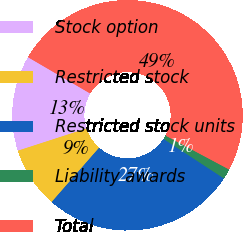Convert chart to OTSL. <chart><loc_0><loc_0><loc_500><loc_500><pie_chart><fcel>Stock option<fcel>Restricted stock<fcel>Restricted stock units<fcel>Liability awards<fcel>Total<nl><fcel>13.39%<fcel>8.59%<fcel>27.2%<fcel>1.43%<fcel>49.39%<nl></chart> 